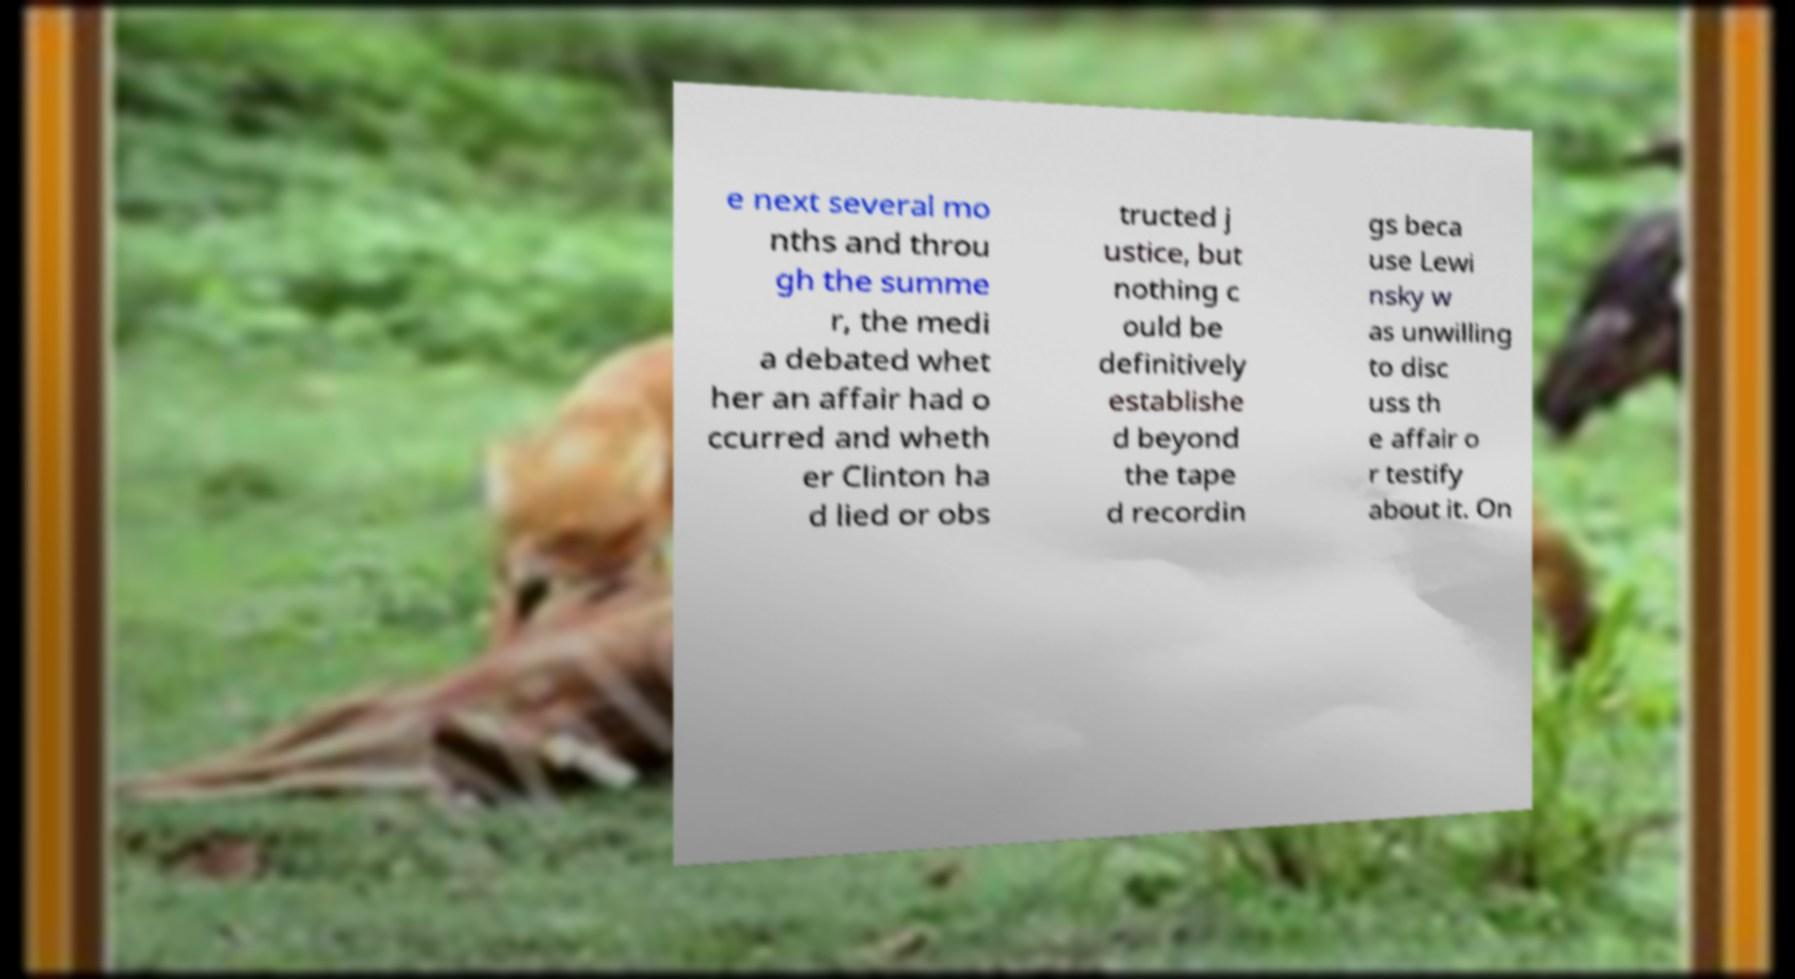Could you assist in decoding the text presented in this image and type it out clearly? e next several mo nths and throu gh the summe r, the medi a debated whet her an affair had o ccurred and wheth er Clinton ha d lied or obs tructed j ustice, but nothing c ould be definitively establishe d beyond the tape d recordin gs beca use Lewi nsky w as unwilling to disc uss th e affair o r testify about it. On 